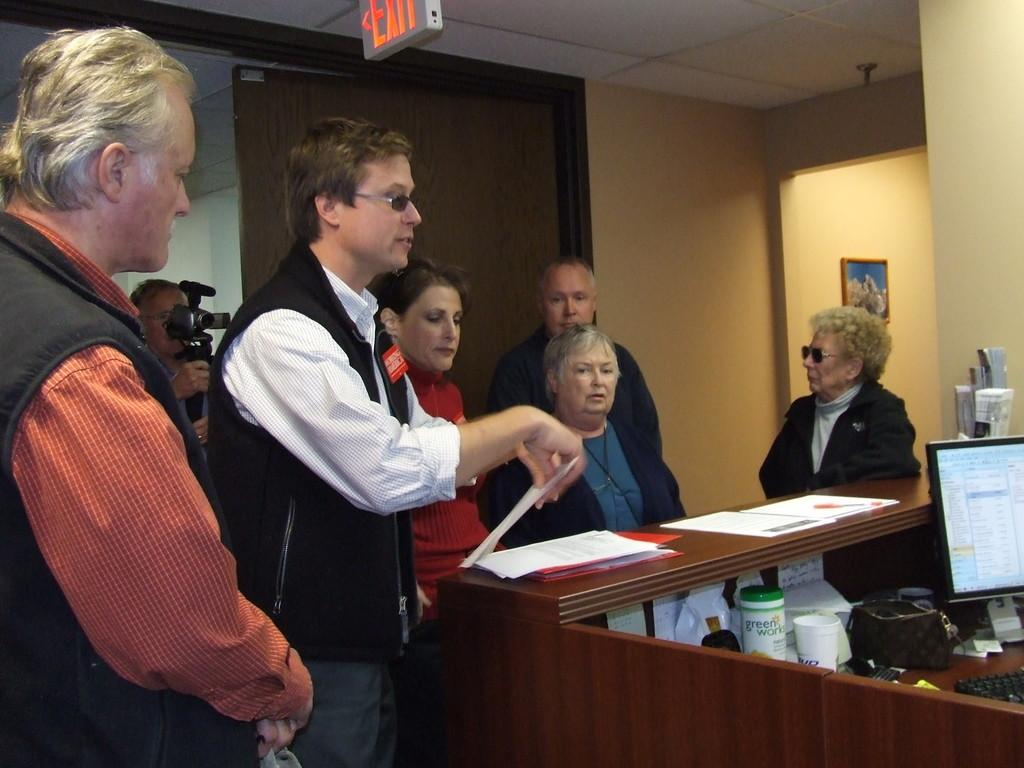Who or what can be seen in the image? There are people in the image. What is the background of the image? There is a wall in the image. Are there any decorative items visible? Yes, there is a photo frame in the image. What else can be seen on the surface where the people are? There are papers and glasses in the image. What type of device is present in the image? There is a screen in the image. What song is being sung by the baby in the image? There is no baby present in the image, and therefore no song can be heard or seen. 